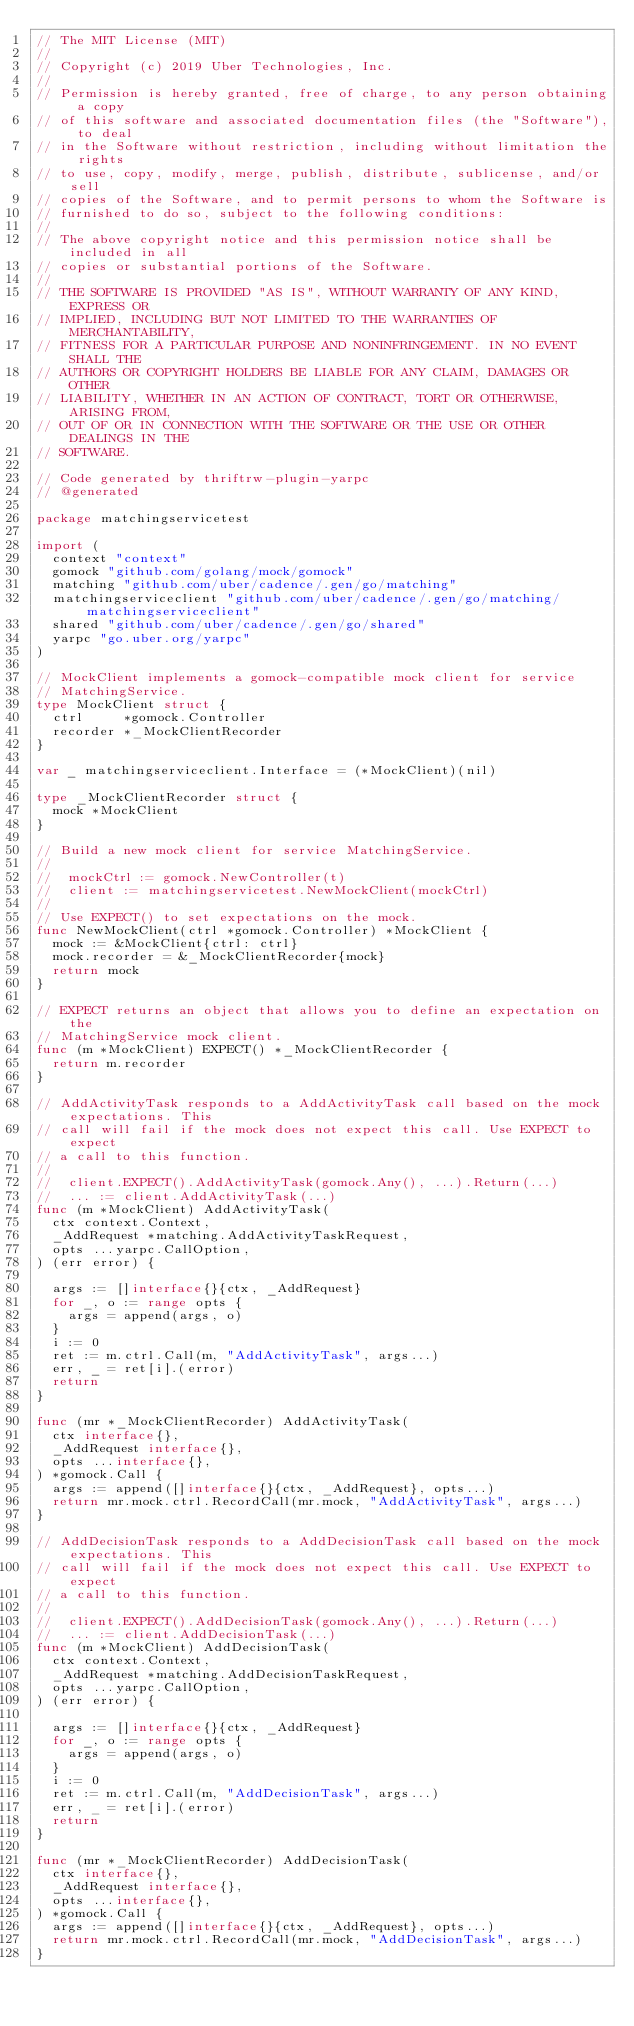<code> <loc_0><loc_0><loc_500><loc_500><_Go_>// The MIT License (MIT)
// 
// Copyright (c) 2019 Uber Technologies, Inc.
// 
// Permission is hereby granted, free of charge, to any person obtaining a copy
// of this software and associated documentation files (the "Software"), to deal
// in the Software without restriction, including without limitation the rights
// to use, copy, modify, merge, publish, distribute, sublicense, and/or sell
// copies of the Software, and to permit persons to whom the Software is
// furnished to do so, subject to the following conditions:
// 
// The above copyright notice and this permission notice shall be included in all
// copies or substantial portions of the Software.
// 
// THE SOFTWARE IS PROVIDED "AS IS", WITHOUT WARRANTY OF ANY KIND, EXPRESS OR
// IMPLIED, INCLUDING BUT NOT LIMITED TO THE WARRANTIES OF MERCHANTABILITY,
// FITNESS FOR A PARTICULAR PURPOSE AND NONINFRINGEMENT. IN NO EVENT SHALL THE
// AUTHORS OR COPYRIGHT HOLDERS BE LIABLE FOR ANY CLAIM, DAMAGES OR OTHER
// LIABILITY, WHETHER IN AN ACTION OF CONTRACT, TORT OR OTHERWISE, ARISING FROM,
// OUT OF OR IN CONNECTION WITH THE SOFTWARE OR THE USE OR OTHER DEALINGS IN THE
// SOFTWARE.

// Code generated by thriftrw-plugin-yarpc
// @generated

package matchingservicetest

import (
	context "context"
	gomock "github.com/golang/mock/gomock"
	matching "github.com/uber/cadence/.gen/go/matching"
	matchingserviceclient "github.com/uber/cadence/.gen/go/matching/matchingserviceclient"
	shared "github.com/uber/cadence/.gen/go/shared"
	yarpc "go.uber.org/yarpc"
)

// MockClient implements a gomock-compatible mock client for service
// MatchingService.
type MockClient struct {
	ctrl     *gomock.Controller
	recorder *_MockClientRecorder
}

var _ matchingserviceclient.Interface = (*MockClient)(nil)

type _MockClientRecorder struct {
	mock *MockClient
}

// Build a new mock client for service MatchingService.
//
// 	mockCtrl := gomock.NewController(t)
// 	client := matchingservicetest.NewMockClient(mockCtrl)
//
// Use EXPECT() to set expectations on the mock.
func NewMockClient(ctrl *gomock.Controller) *MockClient {
	mock := &MockClient{ctrl: ctrl}
	mock.recorder = &_MockClientRecorder{mock}
	return mock
}

// EXPECT returns an object that allows you to define an expectation on the
// MatchingService mock client.
func (m *MockClient) EXPECT() *_MockClientRecorder {
	return m.recorder
}

// AddActivityTask responds to a AddActivityTask call based on the mock expectations. This
// call will fail if the mock does not expect this call. Use EXPECT to expect
// a call to this function.
//
// 	client.EXPECT().AddActivityTask(gomock.Any(), ...).Return(...)
// 	... := client.AddActivityTask(...)
func (m *MockClient) AddActivityTask(
	ctx context.Context,
	_AddRequest *matching.AddActivityTaskRequest,
	opts ...yarpc.CallOption,
) (err error) {

	args := []interface{}{ctx, _AddRequest}
	for _, o := range opts {
		args = append(args, o)
	}
	i := 0
	ret := m.ctrl.Call(m, "AddActivityTask", args...)
	err, _ = ret[i].(error)
	return
}

func (mr *_MockClientRecorder) AddActivityTask(
	ctx interface{},
	_AddRequest interface{},
	opts ...interface{},
) *gomock.Call {
	args := append([]interface{}{ctx, _AddRequest}, opts...)
	return mr.mock.ctrl.RecordCall(mr.mock, "AddActivityTask", args...)
}

// AddDecisionTask responds to a AddDecisionTask call based on the mock expectations. This
// call will fail if the mock does not expect this call. Use EXPECT to expect
// a call to this function.
//
// 	client.EXPECT().AddDecisionTask(gomock.Any(), ...).Return(...)
// 	... := client.AddDecisionTask(...)
func (m *MockClient) AddDecisionTask(
	ctx context.Context,
	_AddRequest *matching.AddDecisionTaskRequest,
	opts ...yarpc.CallOption,
) (err error) {

	args := []interface{}{ctx, _AddRequest}
	for _, o := range opts {
		args = append(args, o)
	}
	i := 0
	ret := m.ctrl.Call(m, "AddDecisionTask", args...)
	err, _ = ret[i].(error)
	return
}

func (mr *_MockClientRecorder) AddDecisionTask(
	ctx interface{},
	_AddRequest interface{},
	opts ...interface{},
) *gomock.Call {
	args := append([]interface{}{ctx, _AddRequest}, opts...)
	return mr.mock.ctrl.RecordCall(mr.mock, "AddDecisionTask", args...)
}
</code> 